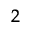<formula> <loc_0><loc_0><loc_500><loc_500>_ { 2 }</formula> 